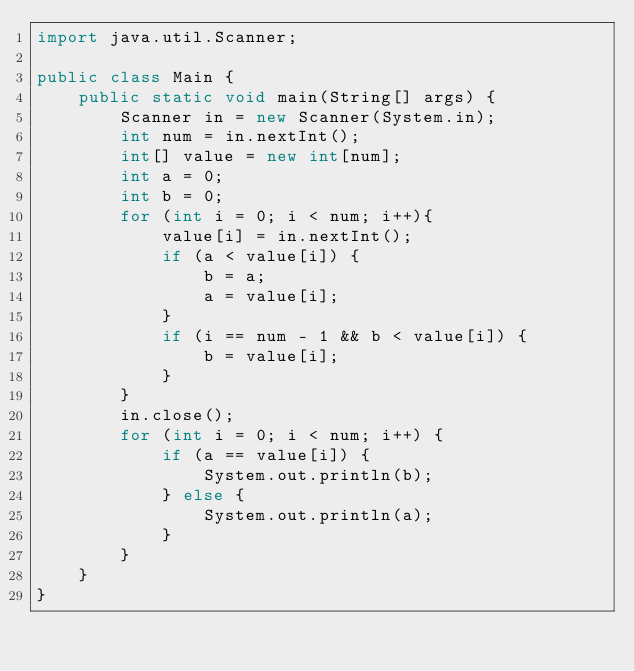<code> <loc_0><loc_0><loc_500><loc_500><_Java_>import java.util.Scanner;

public class Main {
    public static void main(String[] args) {
        Scanner in = new Scanner(System.in);
        int num = in.nextInt();
        int[] value = new int[num];
        int a = 0;
        int b = 0;
        for (int i = 0; i < num; i++){
            value[i] = in.nextInt();
            if (a < value[i]) {
                b = a;
                a = value[i];
            }
            if (i == num - 1 && b < value[i]) {
                b = value[i];
            }
        }
        in.close();
        for (int i = 0; i < num; i++) {
            if (a == value[i]) {
                System.out.println(b);
            } else {
                System.out.println(a);
            }
        }
    }
}
</code> 